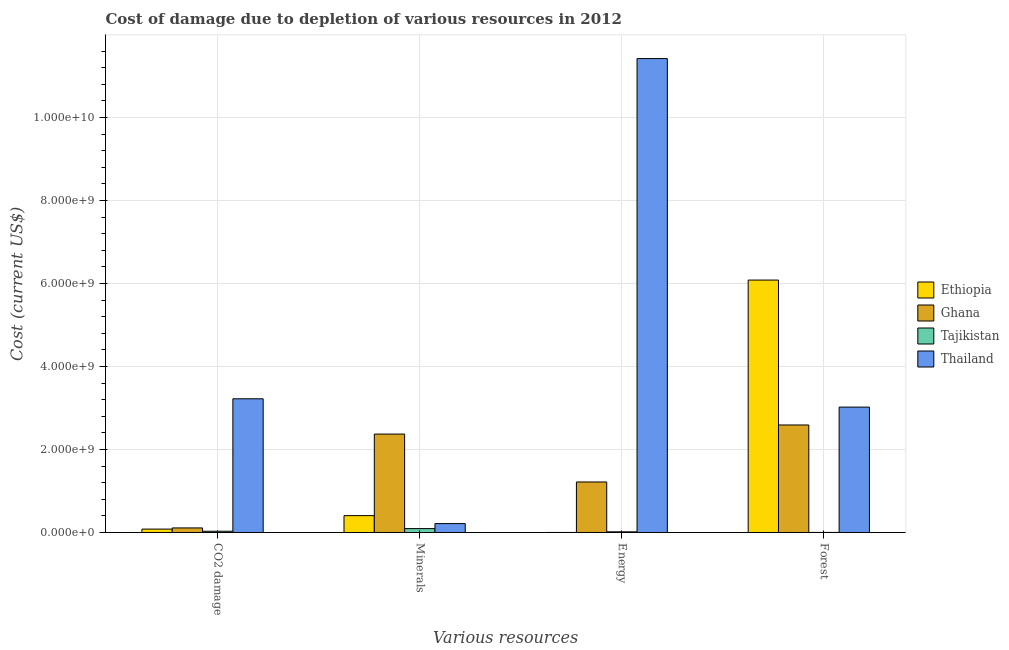How many different coloured bars are there?
Keep it short and to the point. 4. Are the number of bars per tick equal to the number of legend labels?
Provide a succinct answer. Yes. Are the number of bars on each tick of the X-axis equal?
Offer a very short reply. Yes. What is the label of the 2nd group of bars from the left?
Keep it short and to the point. Minerals. What is the cost of damage due to depletion of minerals in Ethiopia?
Ensure brevity in your answer.  4.06e+08. Across all countries, what is the maximum cost of damage due to depletion of coal?
Your answer should be very brief. 3.22e+09. Across all countries, what is the minimum cost of damage due to depletion of coal?
Ensure brevity in your answer.  2.98e+07. In which country was the cost of damage due to depletion of energy maximum?
Provide a succinct answer. Thailand. In which country was the cost of damage due to depletion of coal minimum?
Provide a short and direct response. Tajikistan. What is the total cost of damage due to depletion of energy in the graph?
Make the answer very short. 1.27e+1. What is the difference between the cost of damage due to depletion of forests in Ghana and that in Thailand?
Offer a very short reply. -4.31e+08. What is the difference between the cost of damage due to depletion of minerals in Tajikistan and the cost of damage due to depletion of coal in Ethiopia?
Your response must be concise. 1.19e+07. What is the average cost of damage due to depletion of energy per country?
Provide a succinct answer. 3.16e+09. What is the difference between the cost of damage due to depletion of coal and cost of damage due to depletion of forests in Ethiopia?
Make the answer very short. -6.00e+09. What is the ratio of the cost of damage due to depletion of energy in Ethiopia to that in Thailand?
Make the answer very short. 6.119150882268203e-5. Is the cost of damage due to depletion of energy in Ethiopia less than that in Ghana?
Offer a terse response. Yes. Is the difference between the cost of damage due to depletion of minerals in Ghana and Ethiopia greater than the difference between the cost of damage due to depletion of energy in Ghana and Ethiopia?
Offer a terse response. Yes. What is the difference between the highest and the second highest cost of damage due to depletion of coal?
Provide a short and direct response. 3.11e+09. What is the difference between the highest and the lowest cost of damage due to depletion of energy?
Your answer should be compact. 1.14e+1. What does the 4th bar from the left in CO2 damage represents?
Keep it short and to the point. Thailand. What does the 4th bar from the right in CO2 damage represents?
Offer a terse response. Ethiopia. Are all the bars in the graph horizontal?
Your response must be concise. No. How many countries are there in the graph?
Keep it short and to the point. 4. What is the difference between two consecutive major ticks on the Y-axis?
Provide a succinct answer. 2.00e+09. Does the graph contain any zero values?
Your answer should be very brief. No. Does the graph contain grids?
Give a very brief answer. Yes. Where does the legend appear in the graph?
Keep it short and to the point. Center right. How many legend labels are there?
Your response must be concise. 4. How are the legend labels stacked?
Ensure brevity in your answer.  Vertical. What is the title of the graph?
Provide a succinct answer. Cost of damage due to depletion of various resources in 2012 . Does "Israel" appear as one of the legend labels in the graph?
Make the answer very short. No. What is the label or title of the X-axis?
Provide a short and direct response. Various resources. What is the label or title of the Y-axis?
Provide a short and direct response. Cost (current US$). What is the Cost (current US$) in Ethiopia in CO2 damage?
Provide a short and direct response. 8.17e+07. What is the Cost (current US$) in Ghana in CO2 damage?
Your answer should be very brief. 1.10e+08. What is the Cost (current US$) in Tajikistan in CO2 damage?
Your answer should be very brief. 2.98e+07. What is the Cost (current US$) of Thailand in CO2 damage?
Offer a terse response. 3.22e+09. What is the Cost (current US$) in Ethiopia in Minerals?
Your answer should be compact. 4.06e+08. What is the Cost (current US$) of Ghana in Minerals?
Make the answer very short. 2.37e+09. What is the Cost (current US$) of Tajikistan in Minerals?
Your answer should be compact. 9.36e+07. What is the Cost (current US$) of Thailand in Minerals?
Offer a terse response. 2.14e+08. What is the Cost (current US$) in Ethiopia in Energy?
Your response must be concise. 6.99e+05. What is the Cost (current US$) in Ghana in Energy?
Offer a terse response. 1.22e+09. What is the Cost (current US$) in Tajikistan in Energy?
Provide a succinct answer. 1.61e+07. What is the Cost (current US$) of Thailand in Energy?
Your answer should be compact. 1.14e+1. What is the Cost (current US$) in Ethiopia in Forest?
Your response must be concise. 6.08e+09. What is the Cost (current US$) in Ghana in Forest?
Your response must be concise. 2.59e+09. What is the Cost (current US$) of Tajikistan in Forest?
Offer a terse response. 1.55e+06. What is the Cost (current US$) of Thailand in Forest?
Your answer should be compact. 3.02e+09. Across all Various resources, what is the maximum Cost (current US$) in Ethiopia?
Offer a very short reply. 6.08e+09. Across all Various resources, what is the maximum Cost (current US$) in Ghana?
Provide a short and direct response. 2.59e+09. Across all Various resources, what is the maximum Cost (current US$) in Tajikistan?
Provide a succinct answer. 9.36e+07. Across all Various resources, what is the maximum Cost (current US$) of Thailand?
Ensure brevity in your answer.  1.14e+1. Across all Various resources, what is the minimum Cost (current US$) in Ethiopia?
Your response must be concise. 6.99e+05. Across all Various resources, what is the minimum Cost (current US$) of Ghana?
Offer a terse response. 1.10e+08. Across all Various resources, what is the minimum Cost (current US$) of Tajikistan?
Ensure brevity in your answer.  1.55e+06. Across all Various resources, what is the minimum Cost (current US$) in Thailand?
Your answer should be compact. 2.14e+08. What is the total Cost (current US$) in Ethiopia in the graph?
Make the answer very short. 6.57e+09. What is the total Cost (current US$) of Ghana in the graph?
Your response must be concise. 6.29e+09. What is the total Cost (current US$) of Tajikistan in the graph?
Your answer should be very brief. 1.41e+08. What is the total Cost (current US$) in Thailand in the graph?
Keep it short and to the point. 1.79e+1. What is the difference between the Cost (current US$) of Ethiopia in CO2 damage and that in Minerals?
Provide a short and direct response. -3.24e+08. What is the difference between the Cost (current US$) of Ghana in CO2 damage and that in Minerals?
Your answer should be very brief. -2.26e+09. What is the difference between the Cost (current US$) in Tajikistan in CO2 damage and that in Minerals?
Give a very brief answer. -6.37e+07. What is the difference between the Cost (current US$) in Thailand in CO2 damage and that in Minerals?
Offer a very short reply. 3.01e+09. What is the difference between the Cost (current US$) in Ethiopia in CO2 damage and that in Energy?
Provide a short and direct response. 8.10e+07. What is the difference between the Cost (current US$) of Ghana in CO2 damage and that in Energy?
Provide a short and direct response. -1.11e+09. What is the difference between the Cost (current US$) of Tajikistan in CO2 damage and that in Energy?
Your answer should be very brief. 1.37e+07. What is the difference between the Cost (current US$) of Thailand in CO2 damage and that in Energy?
Offer a terse response. -8.20e+09. What is the difference between the Cost (current US$) in Ethiopia in CO2 damage and that in Forest?
Keep it short and to the point. -6.00e+09. What is the difference between the Cost (current US$) of Ghana in CO2 damage and that in Forest?
Provide a short and direct response. -2.48e+09. What is the difference between the Cost (current US$) of Tajikistan in CO2 damage and that in Forest?
Your answer should be very brief. 2.83e+07. What is the difference between the Cost (current US$) in Thailand in CO2 damage and that in Forest?
Provide a short and direct response. 2.00e+08. What is the difference between the Cost (current US$) in Ethiopia in Minerals and that in Energy?
Keep it short and to the point. 4.06e+08. What is the difference between the Cost (current US$) in Ghana in Minerals and that in Energy?
Keep it short and to the point. 1.15e+09. What is the difference between the Cost (current US$) of Tajikistan in Minerals and that in Energy?
Keep it short and to the point. 7.74e+07. What is the difference between the Cost (current US$) of Thailand in Minerals and that in Energy?
Ensure brevity in your answer.  -1.12e+1. What is the difference between the Cost (current US$) in Ethiopia in Minerals and that in Forest?
Provide a short and direct response. -5.68e+09. What is the difference between the Cost (current US$) in Ghana in Minerals and that in Forest?
Make the answer very short. -2.19e+08. What is the difference between the Cost (current US$) of Tajikistan in Minerals and that in Forest?
Make the answer very short. 9.20e+07. What is the difference between the Cost (current US$) in Thailand in Minerals and that in Forest?
Your answer should be very brief. -2.81e+09. What is the difference between the Cost (current US$) of Ethiopia in Energy and that in Forest?
Give a very brief answer. -6.08e+09. What is the difference between the Cost (current US$) of Ghana in Energy and that in Forest?
Make the answer very short. -1.37e+09. What is the difference between the Cost (current US$) of Tajikistan in Energy and that in Forest?
Keep it short and to the point. 1.46e+07. What is the difference between the Cost (current US$) in Thailand in Energy and that in Forest?
Your answer should be very brief. 8.40e+09. What is the difference between the Cost (current US$) in Ethiopia in CO2 damage and the Cost (current US$) in Ghana in Minerals?
Your answer should be compact. -2.29e+09. What is the difference between the Cost (current US$) of Ethiopia in CO2 damage and the Cost (current US$) of Tajikistan in Minerals?
Your answer should be compact. -1.19e+07. What is the difference between the Cost (current US$) of Ethiopia in CO2 damage and the Cost (current US$) of Thailand in Minerals?
Your answer should be compact. -1.33e+08. What is the difference between the Cost (current US$) of Ghana in CO2 damage and the Cost (current US$) of Tajikistan in Minerals?
Your answer should be compact. 1.63e+07. What is the difference between the Cost (current US$) in Ghana in CO2 damage and the Cost (current US$) in Thailand in Minerals?
Your response must be concise. -1.04e+08. What is the difference between the Cost (current US$) of Tajikistan in CO2 damage and the Cost (current US$) of Thailand in Minerals?
Keep it short and to the point. -1.84e+08. What is the difference between the Cost (current US$) in Ethiopia in CO2 damage and the Cost (current US$) in Ghana in Energy?
Provide a succinct answer. -1.14e+09. What is the difference between the Cost (current US$) in Ethiopia in CO2 damage and the Cost (current US$) in Tajikistan in Energy?
Offer a terse response. 6.56e+07. What is the difference between the Cost (current US$) of Ethiopia in CO2 damage and the Cost (current US$) of Thailand in Energy?
Make the answer very short. -1.13e+1. What is the difference between the Cost (current US$) in Ghana in CO2 damage and the Cost (current US$) in Tajikistan in Energy?
Your response must be concise. 9.37e+07. What is the difference between the Cost (current US$) of Ghana in CO2 damage and the Cost (current US$) of Thailand in Energy?
Make the answer very short. -1.13e+1. What is the difference between the Cost (current US$) of Tajikistan in CO2 damage and the Cost (current US$) of Thailand in Energy?
Your answer should be compact. -1.14e+1. What is the difference between the Cost (current US$) of Ethiopia in CO2 damage and the Cost (current US$) of Ghana in Forest?
Offer a very short reply. -2.51e+09. What is the difference between the Cost (current US$) of Ethiopia in CO2 damage and the Cost (current US$) of Tajikistan in Forest?
Keep it short and to the point. 8.02e+07. What is the difference between the Cost (current US$) of Ethiopia in CO2 damage and the Cost (current US$) of Thailand in Forest?
Offer a very short reply. -2.94e+09. What is the difference between the Cost (current US$) in Ghana in CO2 damage and the Cost (current US$) in Tajikistan in Forest?
Provide a succinct answer. 1.08e+08. What is the difference between the Cost (current US$) in Ghana in CO2 damage and the Cost (current US$) in Thailand in Forest?
Ensure brevity in your answer.  -2.91e+09. What is the difference between the Cost (current US$) in Tajikistan in CO2 damage and the Cost (current US$) in Thailand in Forest?
Provide a succinct answer. -2.99e+09. What is the difference between the Cost (current US$) in Ethiopia in Minerals and the Cost (current US$) in Ghana in Energy?
Give a very brief answer. -8.11e+08. What is the difference between the Cost (current US$) of Ethiopia in Minerals and the Cost (current US$) of Tajikistan in Energy?
Ensure brevity in your answer.  3.90e+08. What is the difference between the Cost (current US$) of Ethiopia in Minerals and the Cost (current US$) of Thailand in Energy?
Give a very brief answer. -1.10e+1. What is the difference between the Cost (current US$) in Ghana in Minerals and the Cost (current US$) in Tajikistan in Energy?
Your answer should be compact. 2.36e+09. What is the difference between the Cost (current US$) of Ghana in Minerals and the Cost (current US$) of Thailand in Energy?
Ensure brevity in your answer.  -9.05e+09. What is the difference between the Cost (current US$) of Tajikistan in Minerals and the Cost (current US$) of Thailand in Energy?
Your answer should be compact. -1.13e+1. What is the difference between the Cost (current US$) in Ethiopia in Minerals and the Cost (current US$) in Ghana in Forest?
Offer a very short reply. -2.18e+09. What is the difference between the Cost (current US$) in Ethiopia in Minerals and the Cost (current US$) in Tajikistan in Forest?
Offer a terse response. 4.05e+08. What is the difference between the Cost (current US$) in Ethiopia in Minerals and the Cost (current US$) in Thailand in Forest?
Your answer should be very brief. -2.61e+09. What is the difference between the Cost (current US$) in Ghana in Minerals and the Cost (current US$) in Tajikistan in Forest?
Give a very brief answer. 2.37e+09. What is the difference between the Cost (current US$) of Ghana in Minerals and the Cost (current US$) of Thailand in Forest?
Make the answer very short. -6.50e+08. What is the difference between the Cost (current US$) in Tajikistan in Minerals and the Cost (current US$) in Thailand in Forest?
Offer a terse response. -2.93e+09. What is the difference between the Cost (current US$) of Ethiopia in Energy and the Cost (current US$) of Ghana in Forest?
Provide a short and direct response. -2.59e+09. What is the difference between the Cost (current US$) in Ethiopia in Energy and the Cost (current US$) in Tajikistan in Forest?
Provide a short and direct response. -8.50e+05. What is the difference between the Cost (current US$) of Ethiopia in Energy and the Cost (current US$) of Thailand in Forest?
Keep it short and to the point. -3.02e+09. What is the difference between the Cost (current US$) in Ghana in Energy and the Cost (current US$) in Tajikistan in Forest?
Offer a very short reply. 1.22e+09. What is the difference between the Cost (current US$) in Ghana in Energy and the Cost (current US$) in Thailand in Forest?
Provide a short and direct response. -1.80e+09. What is the difference between the Cost (current US$) of Tajikistan in Energy and the Cost (current US$) of Thailand in Forest?
Your answer should be very brief. -3.00e+09. What is the average Cost (current US$) of Ethiopia per Various resources?
Offer a very short reply. 1.64e+09. What is the average Cost (current US$) in Ghana per Various resources?
Ensure brevity in your answer.  1.57e+09. What is the average Cost (current US$) in Tajikistan per Various resources?
Give a very brief answer. 3.53e+07. What is the average Cost (current US$) of Thailand per Various resources?
Give a very brief answer. 4.47e+09. What is the difference between the Cost (current US$) of Ethiopia and Cost (current US$) of Ghana in CO2 damage?
Your response must be concise. -2.81e+07. What is the difference between the Cost (current US$) in Ethiopia and Cost (current US$) in Tajikistan in CO2 damage?
Your response must be concise. 5.19e+07. What is the difference between the Cost (current US$) in Ethiopia and Cost (current US$) in Thailand in CO2 damage?
Offer a very short reply. -3.14e+09. What is the difference between the Cost (current US$) in Ghana and Cost (current US$) in Tajikistan in CO2 damage?
Your response must be concise. 8.00e+07. What is the difference between the Cost (current US$) of Ghana and Cost (current US$) of Thailand in CO2 damage?
Give a very brief answer. -3.11e+09. What is the difference between the Cost (current US$) in Tajikistan and Cost (current US$) in Thailand in CO2 damage?
Provide a succinct answer. -3.19e+09. What is the difference between the Cost (current US$) in Ethiopia and Cost (current US$) in Ghana in Minerals?
Your answer should be compact. -1.96e+09. What is the difference between the Cost (current US$) in Ethiopia and Cost (current US$) in Tajikistan in Minerals?
Ensure brevity in your answer.  3.13e+08. What is the difference between the Cost (current US$) in Ethiopia and Cost (current US$) in Thailand in Minerals?
Offer a terse response. 1.92e+08. What is the difference between the Cost (current US$) of Ghana and Cost (current US$) of Tajikistan in Minerals?
Your answer should be compact. 2.28e+09. What is the difference between the Cost (current US$) in Ghana and Cost (current US$) in Thailand in Minerals?
Provide a short and direct response. 2.16e+09. What is the difference between the Cost (current US$) in Tajikistan and Cost (current US$) in Thailand in Minerals?
Make the answer very short. -1.21e+08. What is the difference between the Cost (current US$) of Ethiopia and Cost (current US$) of Ghana in Energy?
Your response must be concise. -1.22e+09. What is the difference between the Cost (current US$) in Ethiopia and Cost (current US$) in Tajikistan in Energy?
Keep it short and to the point. -1.54e+07. What is the difference between the Cost (current US$) in Ethiopia and Cost (current US$) in Thailand in Energy?
Provide a succinct answer. -1.14e+1. What is the difference between the Cost (current US$) of Ghana and Cost (current US$) of Tajikistan in Energy?
Give a very brief answer. 1.20e+09. What is the difference between the Cost (current US$) in Ghana and Cost (current US$) in Thailand in Energy?
Ensure brevity in your answer.  -1.02e+1. What is the difference between the Cost (current US$) of Tajikistan and Cost (current US$) of Thailand in Energy?
Provide a succinct answer. -1.14e+1. What is the difference between the Cost (current US$) in Ethiopia and Cost (current US$) in Ghana in Forest?
Provide a short and direct response. 3.49e+09. What is the difference between the Cost (current US$) in Ethiopia and Cost (current US$) in Tajikistan in Forest?
Make the answer very short. 6.08e+09. What is the difference between the Cost (current US$) of Ethiopia and Cost (current US$) of Thailand in Forest?
Ensure brevity in your answer.  3.06e+09. What is the difference between the Cost (current US$) of Ghana and Cost (current US$) of Tajikistan in Forest?
Your answer should be very brief. 2.59e+09. What is the difference between the Cost (current US$) of Ghana and Cost (current US$) of Thailand in Forest?
Provide a succinct answer. -4.31e+08. What is the difference between the Cost (current US$) in Tajikistan and Cost (current US$) in Thailand in Forest?
Your response must be concise. -3.02e+09. What is the ratio of the Cost (current US$) of Ethiopia in CO2 damage to that in Minerals?
Provide a succinct answer. 0.2. What is the ratio of the Cost (current US$) of Ghana in CO2 damage to that in Minerals?
Your response must be concise. 0.05. What is the ratio of the Cost (current US$) of Tajikistan in CO2 damage to that in Minerals?
Your response must be concise. 0.32. What is the ratio of the Cost (current US$) of Thailand in CO2 damage to that in Minerals?
Make the answer very short. 15.03. What is the ratio of the Cost (current US$) of Ethiopia in CO2 damage to that in Energy?
Your answer should be compact. 116.95. What is the ratio of the Cost (current US$) in Ghana in CO2 damage to that in Energy?
Make the answer very short. 0.09. What is the ratio of the Cost (current US$) of Tajikistan in CO2 damage to that in Energy?
Provide a succinct answer. 1.85. What is the ratio of the Cost (current US$) of Thailand in CO2 damage to that in Energy?
Your response must be concise. 0.28. What is the ratio of the Cost (current US$) of Ethiopia in CO2 damage to that in Forest?
Your answer should be compact. 0.01. What is the ratio of the Cost (current US$) in Ghana in CO2 damage to that in Forest?
Provide a succinct answer. 0.04. What is the ratio of the Cost (current US$) of Tajikistan in CO2 damage to that in Forest?
Your response must be concise. 19.26. What is the ratio of the Cost (current US$) in Thailand in CO2 damage to that in Forest?
Your answer should be very brief. 1.07. What is the ratio of the Cost (current US$) in Ethiopia in Minerals to that in Energy?
Provide a succinct answer. 581.38. What is the ratio of the Cost (current US$) in Ghana in Minerals to that in Energy?
Your answer should be compact. 1.95. What is the ratio of the Cost (current US$) of Tajikistan in Minerals to that in Energy?
Offer a terse response. 5.8. What is the ratio of the Cost (current US$) of Thailand in Minerals to that in Energy?
Your answer should be very brief. 0.02. What is the ratio of the Cost (current US$) in Ethiopia in Minerals to that in Forest?
Offer a terse response. 0.07. What is the ratio of the Cost (current US$) in Ghana in Minerals to that in Forest?
Ensure brevity in your answer.  0.92. What is the ratio of the Cost (current US$) of Tajikistan in Minerals to that in Forest?
Provide a short and direct response. 60.41. What is the ratio of the Cost (current US$) of Thailand in Minerals to that in Forest?
Make the answer very short. 0.07. What is the ratio of the Cost (current US$) of Ethiopia in Energy to that in Forest?
Your answer should be compact. 0. What is the ratio of the Cost (current US$) in Ghana in Energy to that in Forest?
Your answer should be very brief. 0.47. What is the ratio of the Cost (current US$) in Tajikistan in Energy to that in Forest?
Your answer should be compact. 10.41. What is the ratio of the Cost (current US$) in Thailand in Energy to that in Forest?
Offer a very short reply. 3.78. What is the difference between the highest and the second highest Cost (current US$) of Ethiopia?
Provide a succinct answer. 5.68e+09. What is the difference between the highest and the second highest Cost (current US$) of Ghana?
Your response must be concise. 2.19e+08. What is the difference between the highest and the second highest Cost (current US$) in Tajikistan?
Make the answer very short. 6.37e+07. What is the difference between the highest and the second highest Cost (current US$) in Thailand?
Your answer should be compact. 8.20e+09. What is the difference between the highest and the lowest Cost (current US$) in Ethiopia?
Offer a very short reply. 6.08e+09. What is the difference between the highest and the lowest Cost (current US$) of Ghana?
Ensure brevity in your answer.  2.48e+09. What is the difference between the highest and the lowest Cost (current US$) of Tajikistan?
Offer a terse response. 9.20e+07. What is the difference between the highest and the lowest Cost (current US$) of Thailand?
Ensure brevity in your answer.  1.12e+1. 